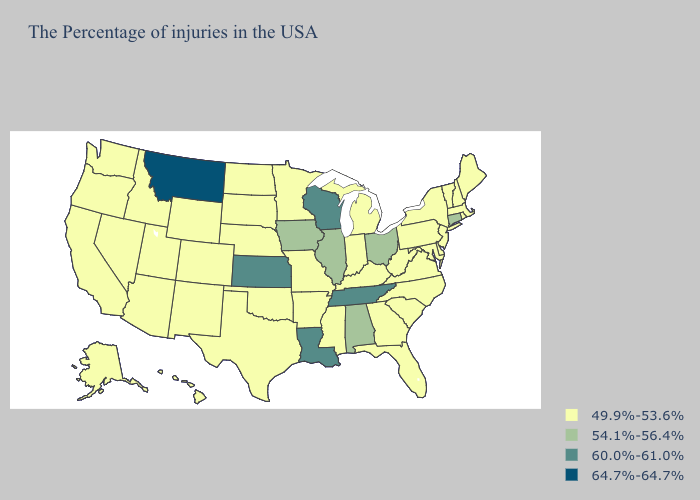What is the value of Louisiana?
Keep it brief. 60.0%-61.0%. Does Connecticut have the highest value in the Northeast?
Keep it brief. Yes. Name the states that have a value in the range 49.9%-53.6%?
Quick response, please. Maine, Massachusetts, Rhode Island, New Hampshire, Vermont, New York, New Jersey, Delaware, Maryland, Pennsylvania, Virginia, North Carolina, South Carolina, West Virginia, Florida, Georgia, Michigan, Kentucky, Indiana, Mississippi, Missouri, Arkansas, Minnesota, Nebraska, Oklahoma, Texas, South Dakota, North Dakota, Wyoming, Colorado, New Mexico, Utah, Arizona, Idaho, Nevada, California, Washington, Oregon, Alaska, Hawaii. What is the value of Idaho?
Keep it brief. 49.9%-53.6%. Name the states that have a value in the range 64.7%-64.7%?
Quick response, please. Montana. Does North Carolina have the highest value in the USA?
Quick response, please. No. Which states have the lowest value in the USA?
Write a very short answer. Maine, Massachusetts, Rhode Island, New Hampshire, Vermont, New York, New Jersey, Delaware, Maryland, Pennsylvania, Virginia, North Carolina, South Carolina, West Virginia, Florida, Georgia, Michigan, Kentucky, Indiana, Mississippi, Missouri, Arkansas, Minnesota, Nebraska, Oklahoma, Texas, South Dakota, North Dakota, Wyoming, Colorado, New Mexico, Utah, Arizona, Idaho, Nevada, California, Washington, Oregon, Alaska, Hawaii. Name the states that have a value in the range 64.7%-64.7%?
Concise answer only. Montana. What is the value of New Jersey?
Keep it brief. 49.9%-53.6%. Does the map have missing data?
Answer briefly. No. Which states hav the highest value in the West?
Short answer required. Montana. What is the highest value in states that border Oregon?
Give a very brief answer. 49.9%-53.6%. Name the states that have a value in the range 49.9%-53.6%?
Quick response, please. Maine, Massachusetts, Rhode Island, New Hampshire, Vermont, New York, New Jersey, Delaware, Maryland, Pennsylvania, Virginia, North Carolina, South Carolina, West Virginia, Florida, Georgia, Michigan, Kentucky, Indiana, Mississippi, Missouri, Arkansas, Minnesota, Nebraska, Oklahoma, Texas, South Dakota, North Dakota, Wyoming, Colorado, New Mexico, Utah, Arizona, Idaho, Nevada, California, Washington, Oregon, Alaska, Hawaii. How many symbols are there in the legend?
Quick response, please. 4. Name the states that have a value in the range 60.0%-61.0%?
Write a very short answer. Tennessee, Wisconsin, Louisiana, Kansas. 